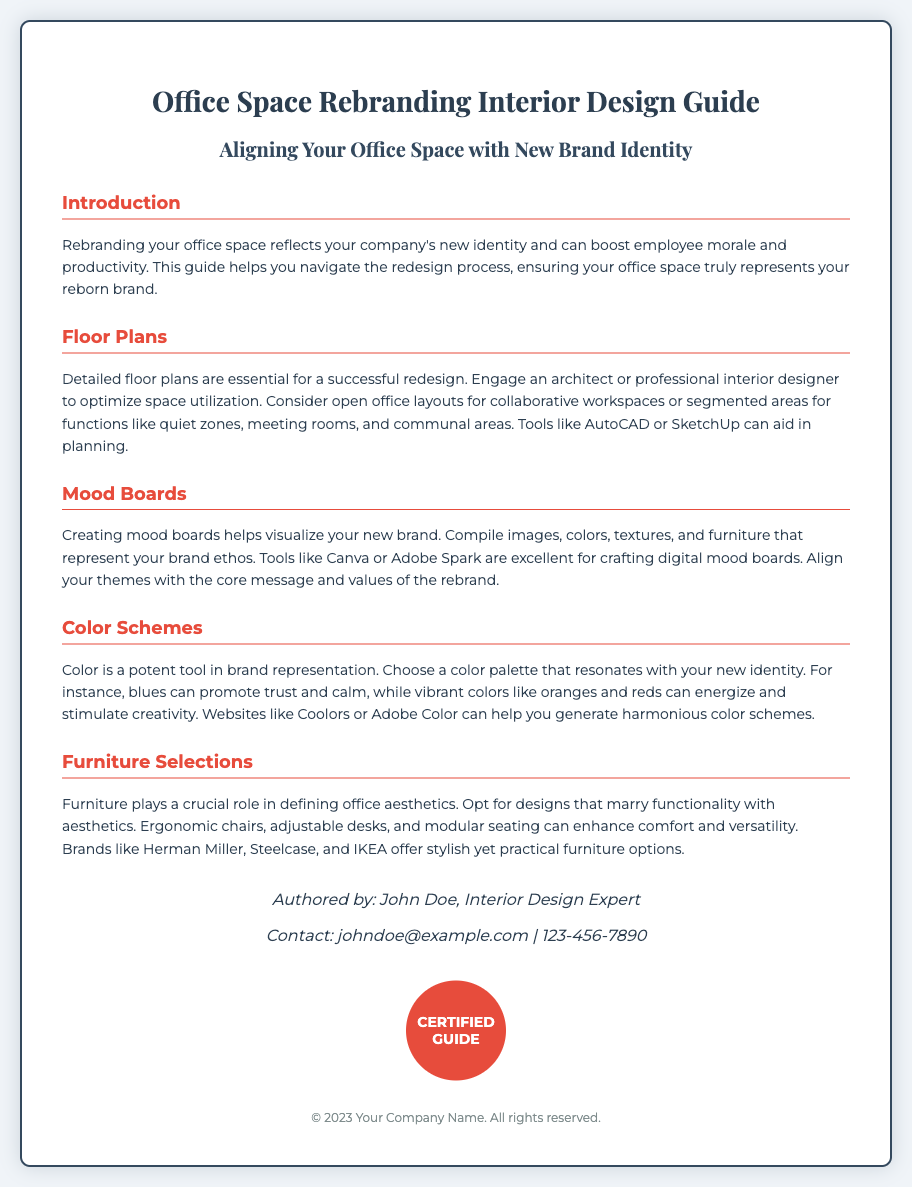what is the title of the guide? The title is prominently displayed at the top of the document, which provides the theme of the content.
Answer: Office Space Rebranding Interior Design Guide who is the author of the guide? The author's name is mentioned towards the end of the document, indicating expertise in the field of interior design.
Answer: John Doe what is one tool recommended for creating mood boards? The document suggests specific tools for crafting digital mood boards, which facilitates the design process.
Answer: Canva what does the color blue promote according to the document? The document highlights the impact of colors on brand representation, specifically mentioning the psychological effects of blue.
Answer: Trust and calm which brand is mentioned as a furniture option? The document lists several brands known for their office furniture, implying quality and style suitable for the office space.
Answer: Herman Miller what type of layouts are suggested for collaborative workspaces? The document advises on various office layouts, addressing the different functions of workspaces.
Answer: Open office layouts how many sections are included in the guide? The sections in the document categorize information for better understanding and navigation throughout the guide.
Answer: Five what does the seal in the document signify? The seal appears at the bottom, signifying the authenticity and certification of the guide.
Answer: CERTIFIED GUIDE what is the primary psychological effect of vibrant colors mentioned? The document refers to the psychological impact of colors, particularly vibrant ones, on the work environment.
Answer: Energize and stimulate creativity 